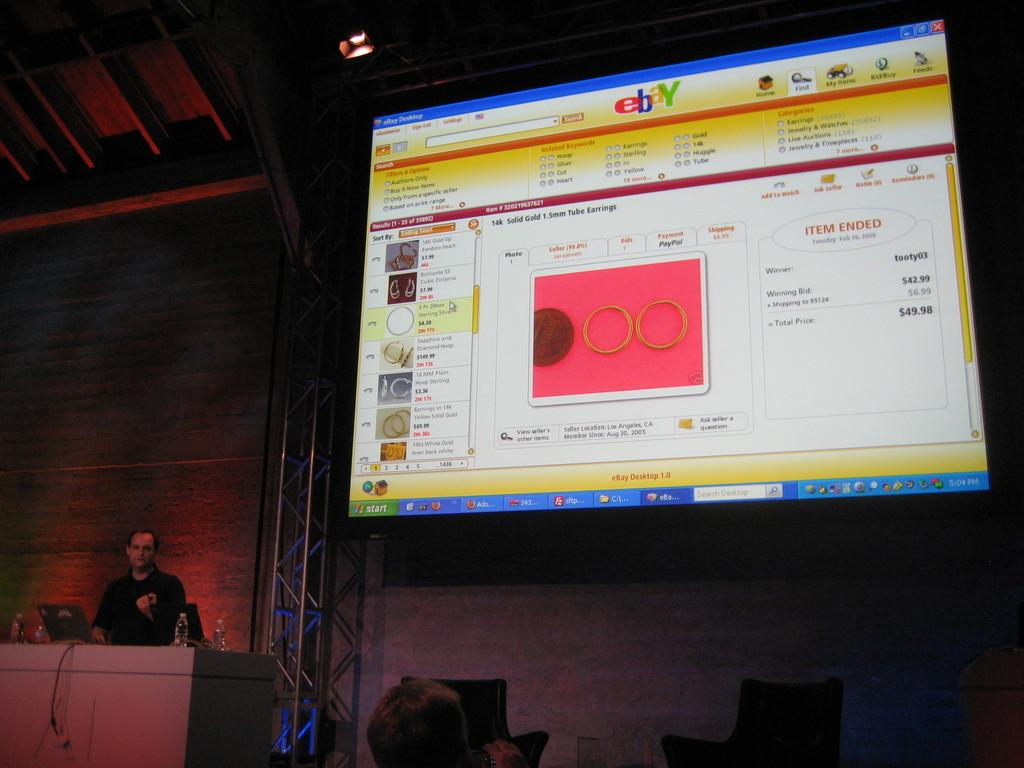<image>
Render a clear and concise summary of the photo. Person giving a presentation in front of a monitor for Ebay. 